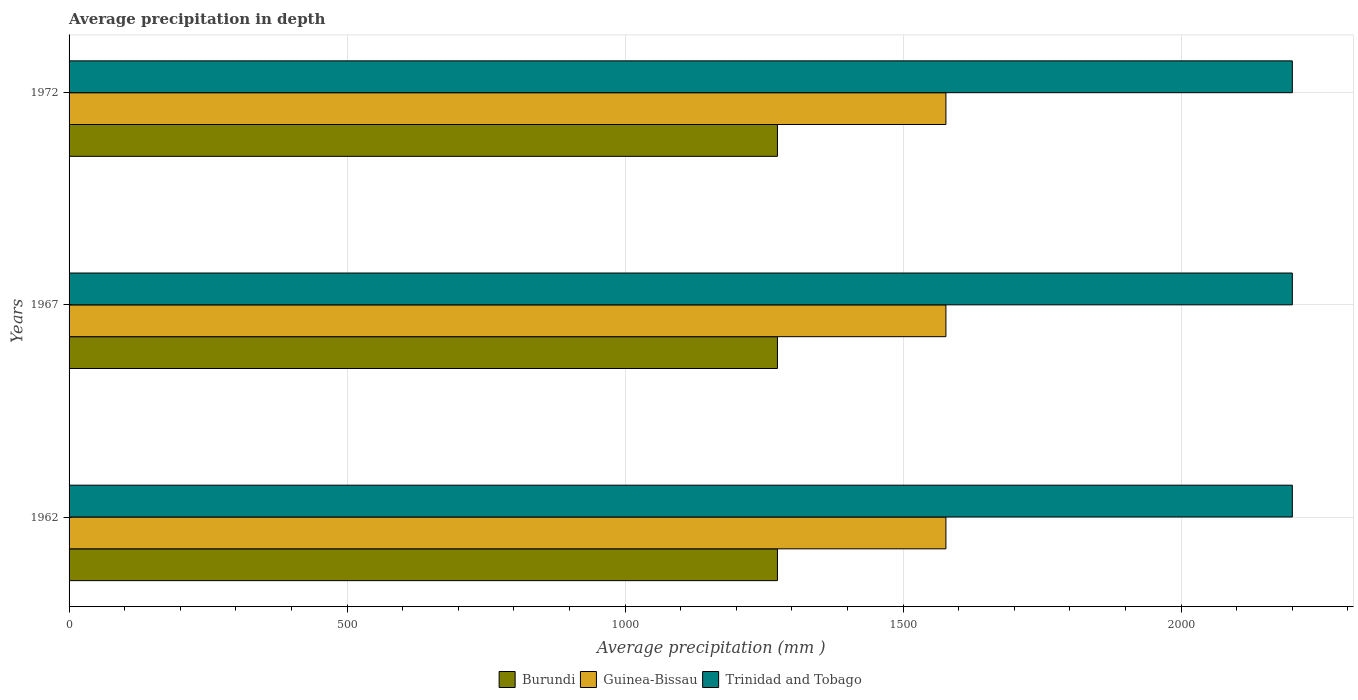How many different coloured bars are there?
Keep it short and to the point. 3. How many groups of bars are there?
Provide a short and direct response. 3. Are the number of bars per tick equal to the number of legend labels?
Your response must be concise. Yes. Are the number of bars on each tick of the Y-axis equal?
Give a very brief answer. Yes. How many bars are there on the 1st tick from the top?
Keep it short and to the point. 3. In how many cases, is the number of bars for a given year not equal to the number of legend labels?
Keep it short and to the point. 0. What is the average precipitation in Guinea-Bissau in 1962?
Keep it short and to the point. 1577. Across all years, what is the maximum average precipitation in Trinidad and Tobago?
Provide a short and direct response. 2200. Across all years, what is the minimum average precipitation in Guinea-Bissau?
Provide a short and direct response. 1577. In which year was the average precipitation in Trinidad and Tobago maximum?
Your response must be concise. 1962. What is the total average precipitation in Guinea-Bissau in the graph?
Offer a very short reply. 4731. What is the difference between the average precipitation in Guinea-Bissau in 1962 and that in 1972?
Offer a very short reply. 0. What is the difference between the average precipitation in Guinea-Bissau in 1967 and the average precipitation in Burundi in 1972?
Offer a terse response. 303. What is the average average precipitation in Trinidad and Tobago per year?
Keep it short and to the point. 2200. In the year 1962, what is the difference between the average precipitation in Trinidad and Tobago and average precipitation in Burundi?
Your response must be concise. 926. In how many years, is the average precipitation in Trinidad and Tobago greater than 500 mm?
Ensure brevity in your answer.  3. Is the average precipitation in Guinea-Bissau in 1962 less than that in 1967?
Make the answer very short. No. Is the difference between the average precipitation in Trinidad and Tobago in 1967 and 1972 greater than the difference between the average precipitation in Burundi in 1967 and 1972?
Your answer should be very brief. No. What is the difference between the highest and the second highest average precipitation in Trinidad and Tobago?
Make the answer very short. 0. What is the difference between the highest and the lowest average precipitation in Guinea-Bissau?
Make the answer very short. 0. In how many years, is the average precipitation in Guinea-Bissau greater than the average average precipitation in Guinea-Bissau taken over all years?
Offer a terse response. 0. Is the sum of the average precipitation in Guinea-Bissau in 1962 and 1967 greater than the maximum average precipitation in Burundi across all years?
Provide a short and direct response. Yes. What does the 2nd bar from the top in 1962 represents?
Offer a terse response. Guinea-Bissau. What does the 1st bar from the bottom in 1967 represents?
Provide a short and direct response. Burundi. Is it the case that in every year, the sum of the average precipitation in Burundi and average precipitation in Guinea-Bissau is greater than the average precipitation in Trinidad and Tobago?
Your answer should be very brief. Yes. Are all the bars in the graph horizontal?
Your response must be concise. Yes. Does the graph contain any zero values?
Provide a succinct answer. No. Does the graph contain grids?
Provide a succinct answer. Yes. How many legend labels are there?
Ensure brevity in your answer.  3. What is the title of the graph?
Offer a very short reply. Average precipitation in depth. Does "Iraq" appear as one of the legend labels in the graph?
Your answer should be very brief. No. What is the label or title of the X-axis?
Offer a terse response. Average precipitation (mm ). What is the Average precipitation (mm ) in Burundi in 1962?
Provide a short and direct response. 1274. What is the Average precipitation (mm ) of Guinea-Bissau in 1962?
Your answer should be compact. 1577. What is the Average precipitation (mm ) of Trinidad and Tobago in 1962?
Keep it short and to the point. 2200. What is the Average precipitation (mm ) in Burundi in 1967?
Make the answer very short. 1274. What is the Average precipitation (mm ) of Guinea-Bissau in 1967?
Make the answer very short. 1577. What is the Average precipitation (mm ) of Trinidad and Tobago in 1967?
Offer a terse response. 2200. What is the Average precipitation (mm ) in Burundi in 1972?
Provide a succinct answer. 1274. What is the Average precipitation (mm ) in Guinea-Bissau in 1972?
Provide a succinct answer. 1577. What is the Average precipitation (mm ) in Trinidad and Tobago in 1972?
Your answer should be very brief. 2200. Across all years, what is the maximum Average precipitation (mm ) in Burundi?
Offer a very short reply. 1274. Across all years, what is the maximum Average precipitation (mm ) in Guinea-Bissau?
Keep it short and to the point. 1577. Across all years, what is the maximum Average precipitation (mm ) in Trinidad and Tobago?
Your answer should be very brief. 2200. Across all years, what is the minimum Average precipitation (mm ) in Burundi?
Provide a succinct answer. 1274. Across all years, what is the minimum Average precipitation (mm ) in Guinea-Bissau?
Ensure brevity in your answer.  1577. Across all years, what is the minimum Average precipitation (mm ) of Trinidad and Tobago?
Provide a succinct answer. 2200. What is the total Average precipitation (mm ) of Burundi in the graph?
Ensure brevity in your answer.  3822. What is the total Average precipitation (mm ) of Guinea-Bissau in the graph?
Offer a very short reply. 4731. What is the total Average precipitation (mm ) of Trinidad and Tobago in the graph?
Offer a terse response. 6600. What is the difference between the Average precipitation (mm ) in Burundi in 1962 and that in 1972?
Make the answer very short. 0. What is the difference between the Average precipitation (mm ) of Guinea-Bissau in 1962 and that in 1972?
Your answer should be very brief. 0. What is the difference between the Average precipitation (mm ) of Trinidad and Tobago in 1962 and that in 1972?
Provide a short and direct response. 0. What is the difference between the Average precipitation (mm ) of Guinea-Bissau in 1967 and that in 1972?
Offer a very short reply. 0. What is the difference between the Average precipitation (mm ) of Trinidad and Tobago in 1967 and that in 1972?
Ensure brevity in your answer.  0. What is the difference between the Average precipitation (mm ) of Burundi in 1962 and the Average precipitation (mm ) of Guinea-Bissau in 1967?
Offer a very short reply. -303. What is the difference between the Average precipitation (mm ) in Burundi in 1962 and the Average precipitation (mm ) in Trinidad and Tobago in 1967?
Make the answer very short. -926. What is the difference between the Average precipitation (mm ) in Guinea-Bissau in 1962 and the Average precipitation (mm ) in Trinidad and Tobago in 1967?
Your answer should be compact. -623. What is the difference between the Average precipitation (mm ) of Burundi in 1962 and the Average precipitation (mm ) of Guinea-Bissau in 1972?
Give a very brief answer. -303. What is the difference between the Average precipitation (mm ) of Burundi in 1962 and the Average precipitation (mm ) of Trinidad and Tobago in 1972?
Your answer should be compact. -926. What is the difference between the Average precipitation (mm ) of Guinea-Bissau in 1962 and the Average precipitation (mm ) of Trinidad and Tobago in 1972?
Provide a short and direct response. -623. What is the difference between the Average precipitation (mm ) in Burundi in 1967 and the Average precipitation (mm ) in Guinea-Bissau in 1972?
Ensure brevity in your answer.  -303. What is the difference between the Average precipitation (mm ) of Burundi in 1967 and the Average precipitation (mm ) of Trinidad and Tobago in 1972?
Your answer should be compact. -926. What is the difference between the Average precipitation (mm ) in Guinea-Bissau in 1967 and the Average precipitation (mm ) in Trinidad and Tobago in 1972?
Offer a terse response. -623. What is the average Average precipitation (mm ) of Burundi per year?
Your answer should be very brief. 1274. What is the average Average precipitation (mm ) in Guinea-Bissau per year?
Make the answer very short. 1577. What is the average Average precipitation (mm ) in Trinidad and Tobago per year?
Your answer should be compact. 2200. In the year 1962, what is the difference between the Average precipitation (mm ) of Burundi and Average precipitation (mm ) of Guinea-Bissau?
Your response must be concise. -303. In the year 1962, what is the difference between the Average precipitation (mm ) in Burundi and Average precipitation (mm ) in Trinidad and Tobago?
Provide a succinct answer. -926. In the year 1962, what is the difference between the Average precipitation (mm ) of Guinea-Bissau and Average precipitation (mm ) of Trinidad and Tobago?
Your response must be concise. -623. In the year 1967, what is the difference between the Average precipitation (mm ) in Burundi and Average precipitation (mm ) in Guinea-Bissau?
Ensure brevity in your answer.  -303. In the year 1967, what is the difference between the Average precipitation (mm ) of Burundi and Average precipitation (mm ) of Trinidad and Tobago?
Your answer should be very brief. -926. In the year 1967, what is the difference between the Average precipitation (mm ) of Guinea-Bissau and Average precipitation (mm ) of Trinidad and Tobago?
Provide a succinct answer. -623. In the year 1972, what is the difference between the Average precipitation (mm ) of Burundi and Average precipitation (mm ) of Guinea-Bissau?
Offer a very short reply. -303. In the year 1972, what is the difference between the Average precipitation (mm ) in Burundi and Average precipitation (mm ) in Trinidad and Tobago?
Make the answer very short. -926. In the year 1972, what is the difference between the Average precipitation (mm ) in Guinea-Bissau and Average precipitation (mm ) in Trinidad and Tobago?
Keep it short and to the point. -623. What is the ratio of the Average precipitation (mm ) of Burundi in 1962 to that in 1967?
Ensure brevity in your answer.  1. What is the ratio of the Average precipitation (mm ) of Guinea-Bissau in 1962 to that in 1967?
Your answer should be compact. 1. What is the ratio of the Average precipitation (mm ) of Burundi in 1962 to that in 1972?
Provide a succinct answer. 1. What is the ratio of the Average precipitation (mm ) of Guinea-Bissau in 1962 to that in 1972?
Make the answer very short. 1. What is the ratio of the Average precipitation (mm ) in Burundi in 1967 to that in 1972?
Provide a short and direct response. 1. What is the ratio of the Average precipitation (mm ) in Guinea-Bissau in 1967 to that in 1972?
Make the answer very short. 1. What is the ratio of the Average precipitation (mm ) in Trinidad and Tobago in 1967 to that in 1972?
Keep it short and to the point. 1. What is the difference between the highest and the second highest Average precipitation (mm ) in Guinea-Bissau?
Your answer should be compact. 0. What is the difference between the highest and the second highest Average precipitation (mm ) of Trinidad and Tobago?
Your response must be concise. 0. What is the difference between the highest and the lowest Average precipitation (mm ) in Burundi?
Provide a short and direct response. 0. What is the difference between the highest and the lowest Average precipitation (mm ) in Trinidad and Tobago?
Offer a very short reply. 0. 